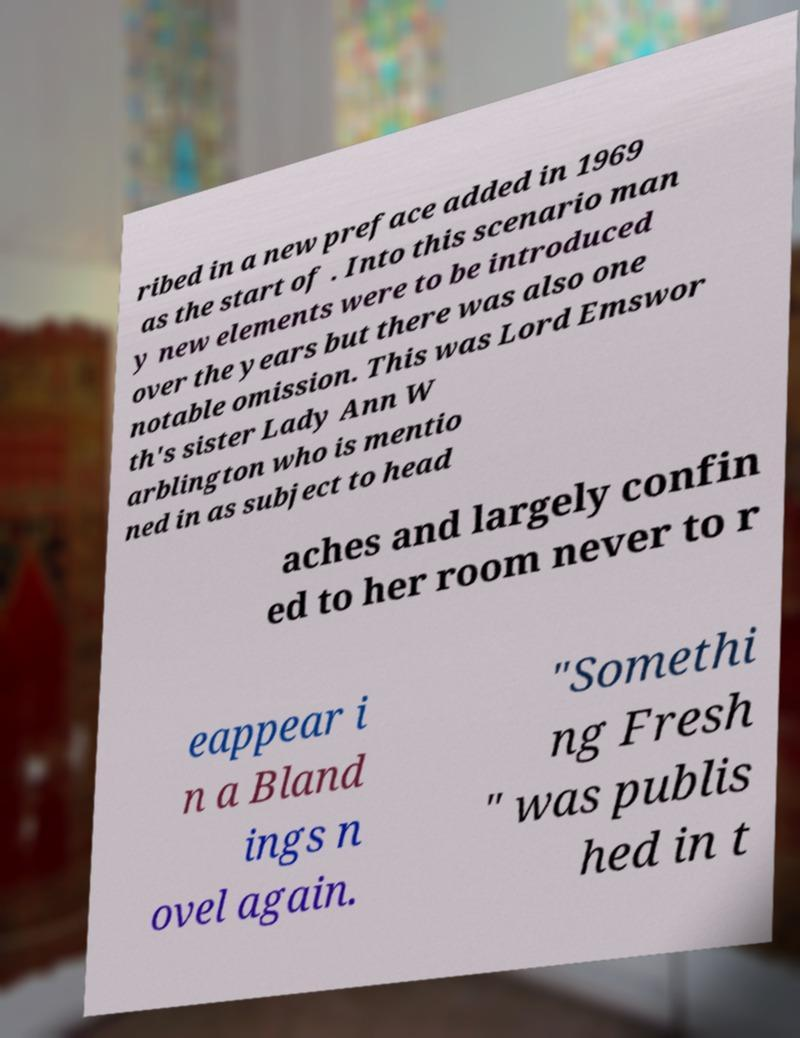Could you extract and type out the text from this image? ribed in a new preface added in 1969 as the start of . Into this scenario man y new elements were to be introduced over the years but there was also one notable omission. This was Lord Emswor th's sister Lady Ann W arblington who is mentio ned in as subject to head aches and largely confin ed to her room never to r eappear i n a Bland ings n ovel again. "Somethi ng Fresh " was publis hed in t 